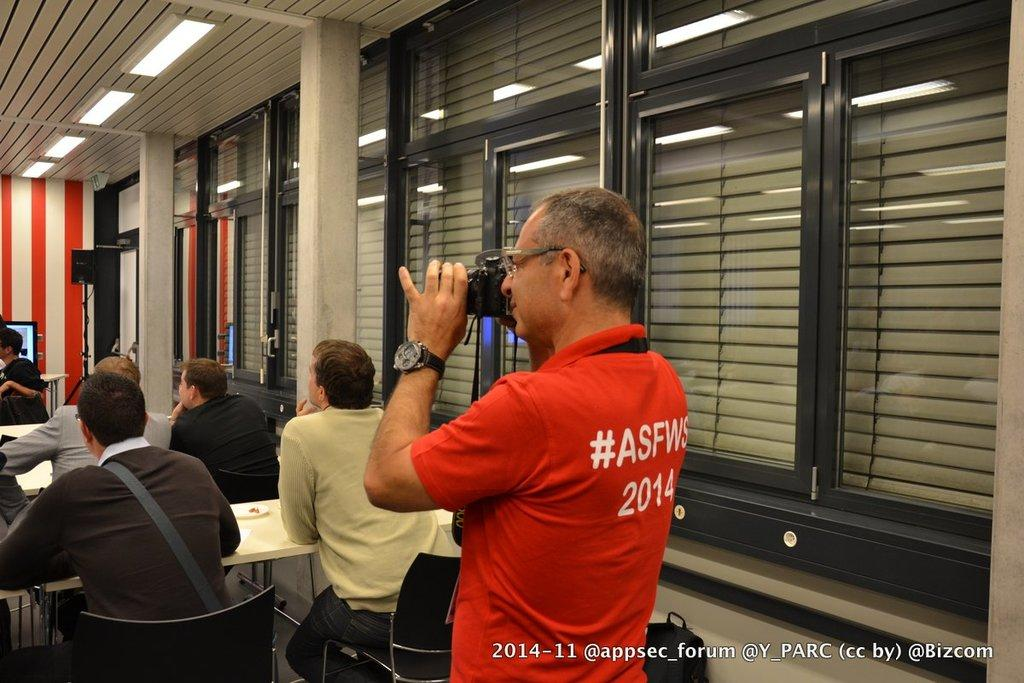What is the person in the image wearing? The person is wearing a red dress in the image. What is the person in the red dress doing? The person is standing and holding a camera in their hands. What are the other people in the image doing? The other people are sitting in chairs in the image. What type of relation does the person in the red dress have with the people sitting in chairs? The image does not provide information about the relationship between the person in the red dress and the people sitting in chairs. 